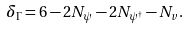Convert formula to latex. <formula><loc_0><loc_0><loc_500><loc_500>\delta _ { \Gamma } = 6 - 2 N _ { \psi } - 2 N _ { \psi ^ { \dag } } - N _ { v } .</formula> 